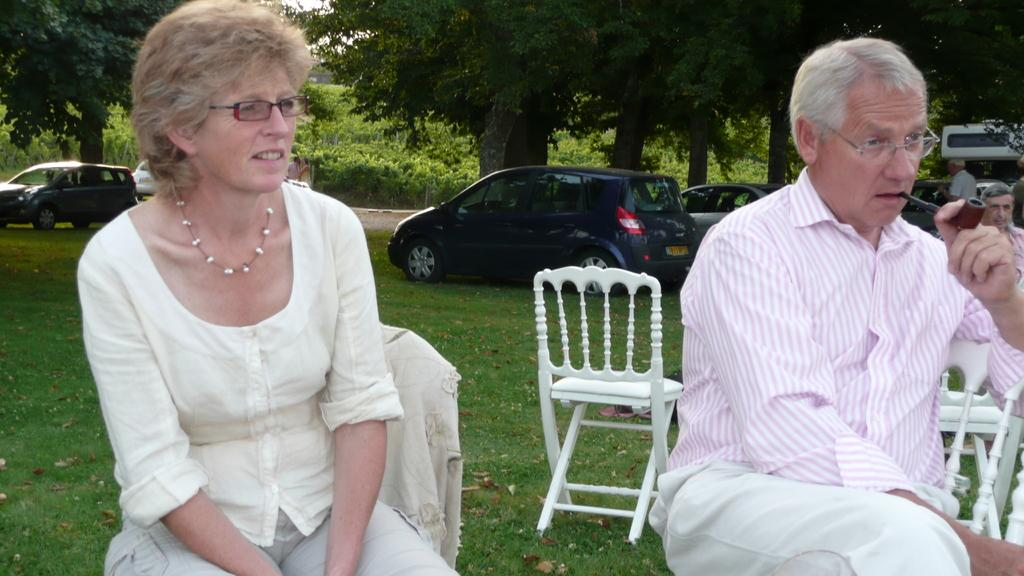What is the woman doing in the image? The woman is sitting in a chair. Who else is sitting in the image? There is a man sitting on the right side. What can be seen in the background of the image? Cars and trees are visible in the image. What type of cushion is the dad using in the image? There is no dad present in the image, and therefore no cushion can be associated with him. 